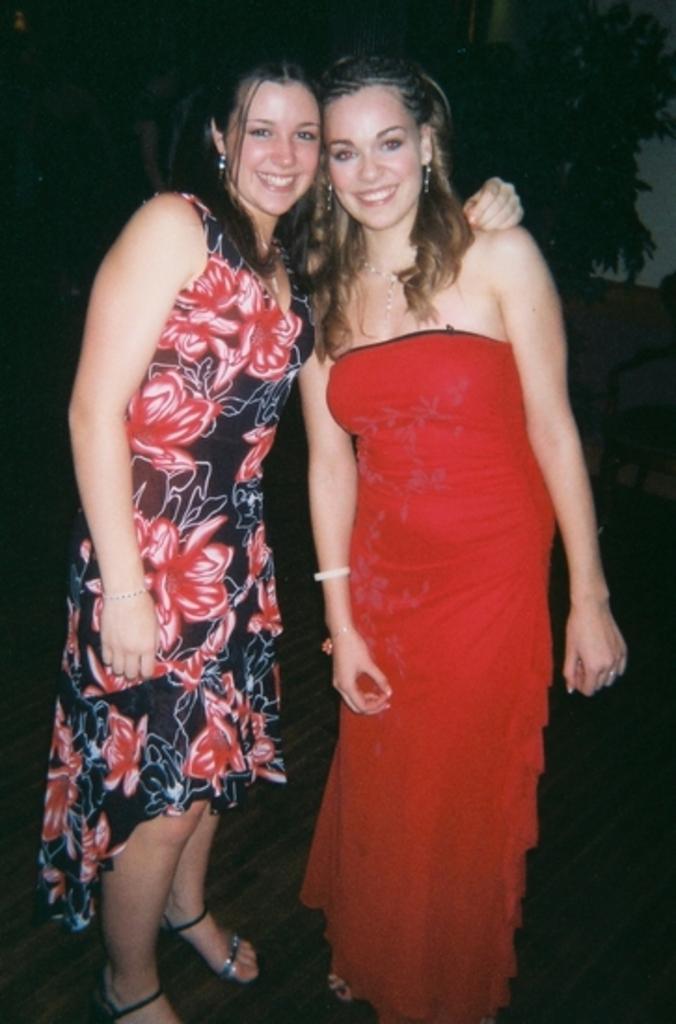How would you summarize this image in a sentence or two? In this picture there are two women standing and smiling. In the background of the image it is dark. 